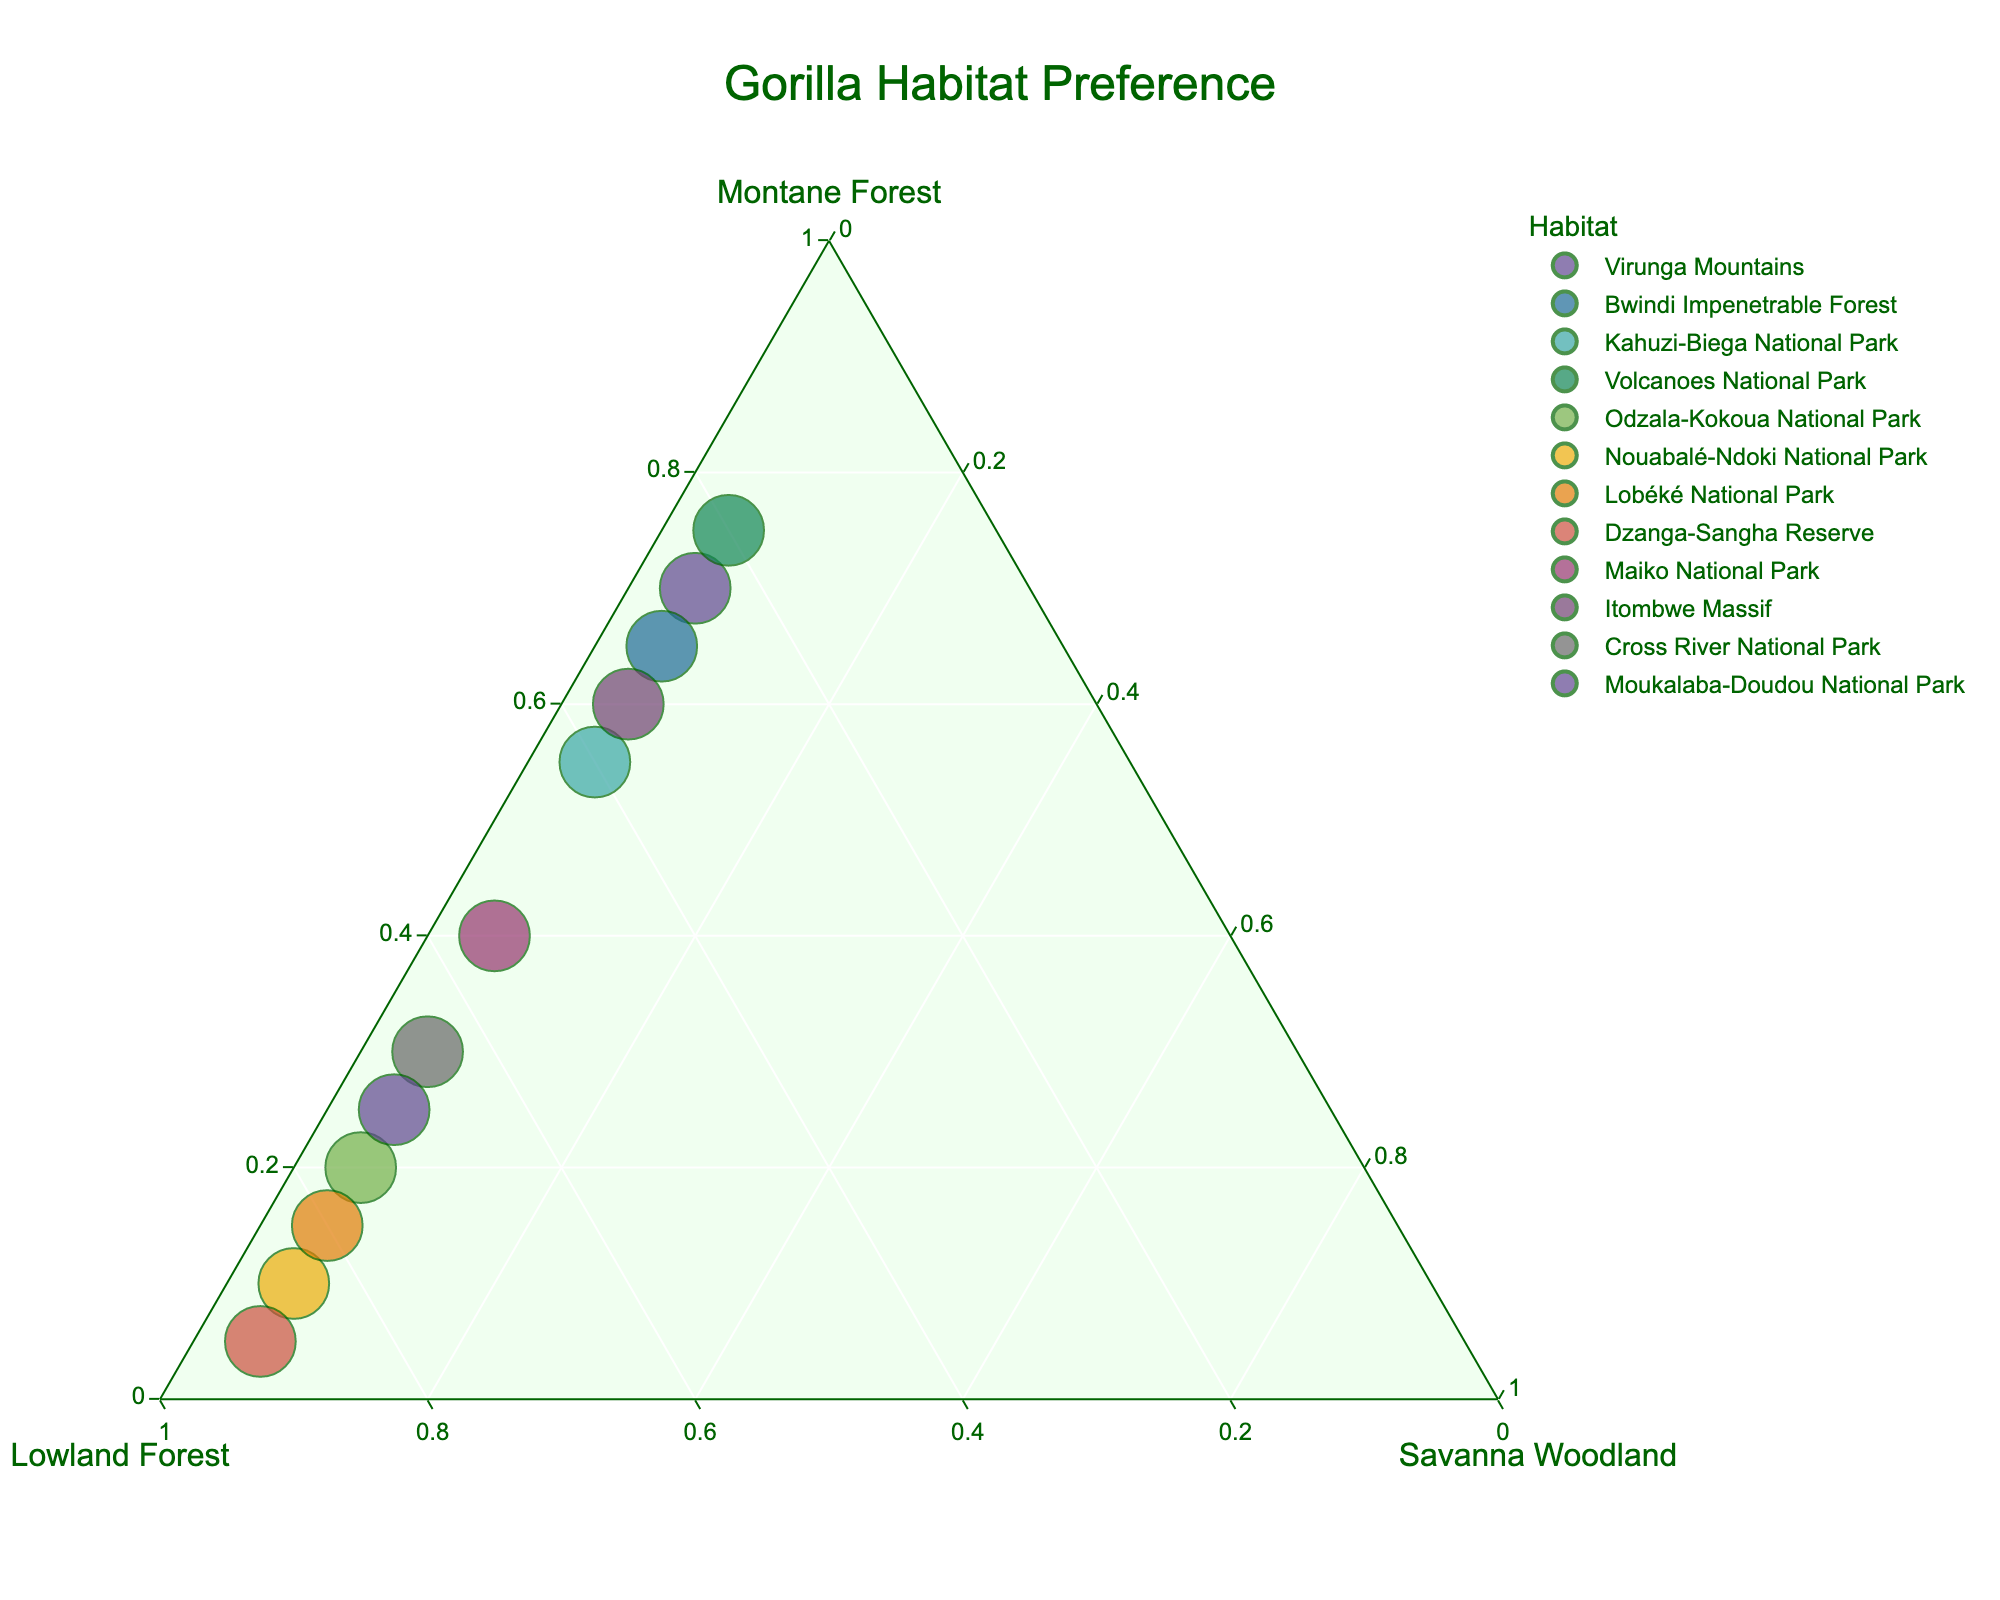1. What is the title of the figure? The title of the figure is usually displayed prominently at the top of the plot. In this case, it should help identify what the chart is about.
Answer: Gorilla Habitat Preference 2. Which habitat has the highest preference for the Lowland Forest? The data point closest to the lowland forest vertex of the ternary plot represents the habitat with the highest preference for Lowland Forest.
Answer: Dzanga-Sangha Reserve 3. How many habitats show at least 50% preference for Montane Forest? Look for data points that are closer to the Montane Forest corner. Montane Forest preferences greater than 50% will be located in the region nearest to the Montane Forest vertex and above the midline.
Answer: 5 4. Comparing Bwindi Impenetrable Forest and Volcanoes National Park, which has a higher preference for the Montane Forest? Locate the data points for both habitats and compare their positions relative to the Montane Forest vertex. The one closer has a higher preference.
Answer: Volcanoes National Park 5. What is the range of preference (%) for Montane Forest across all habitats? The lowest value is closest to 0% Montane Forest, while the highest is nearest to 100%. Identifying these values gives us the range. The minimum Montane Forest preference is 5%, and the maximum is 75%.
Answer: 5% to 75% 6. What is the average preference for Lowland Forest across all habitats? Sum the Lowland Forest % values across all habitats and divide by the number of habitats to get the average. ((25+30+40+20+75+85+80+90+55+35+65+70) / 12)
Answer: 53.75% 7. Which habitat has an equal percentage preference for Montane and Lowland Forests? Look for the data point where the Montane Forest % is equal to the Lowland Forest %.
Answer: Maiko National Park 8. How many habitats have exactly 5% preference for Savanna Woodland? Count the number of data points situated along the line labeled with 5% Savanna Woodland.
Answer: 12 9. Is there any habitat with a higher preference for Savanna Woodland than for Montane Forest or Lowland Forest? Since the data plots only represent gorilla habitats and all have exactly 5% in Savanna Woodland, none can have a higher preference for Savanna Woodland compared to others.
Answer: No 10. Which habitat shares nearly the same preference percentages for all three types of forests? Look for data points near the central area of the ternary plot, indicating similar percentages for all three categories.
Answer: None 